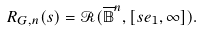Convert formula to latex. <formula><loc_0><loc_0><loc_500><loc_500>R _ { G , n } ( s ) = \mathcal { R } ( \overline { \mathbb { B } } ^ { n } , [ s e _ { 1 } , \infty ] ) .</formula> 